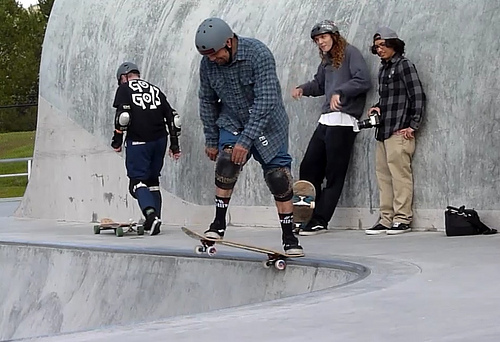Describe the surroundings of the skating area. The skating area is an outdoor concrete skate park with a smooth surface and curved structures designed for performing tricks and maneuvers. The environment suggests a community park, dedicated to skateboarding, which provides a safe and structured place for enthusiasts to gather and practice their skills. 